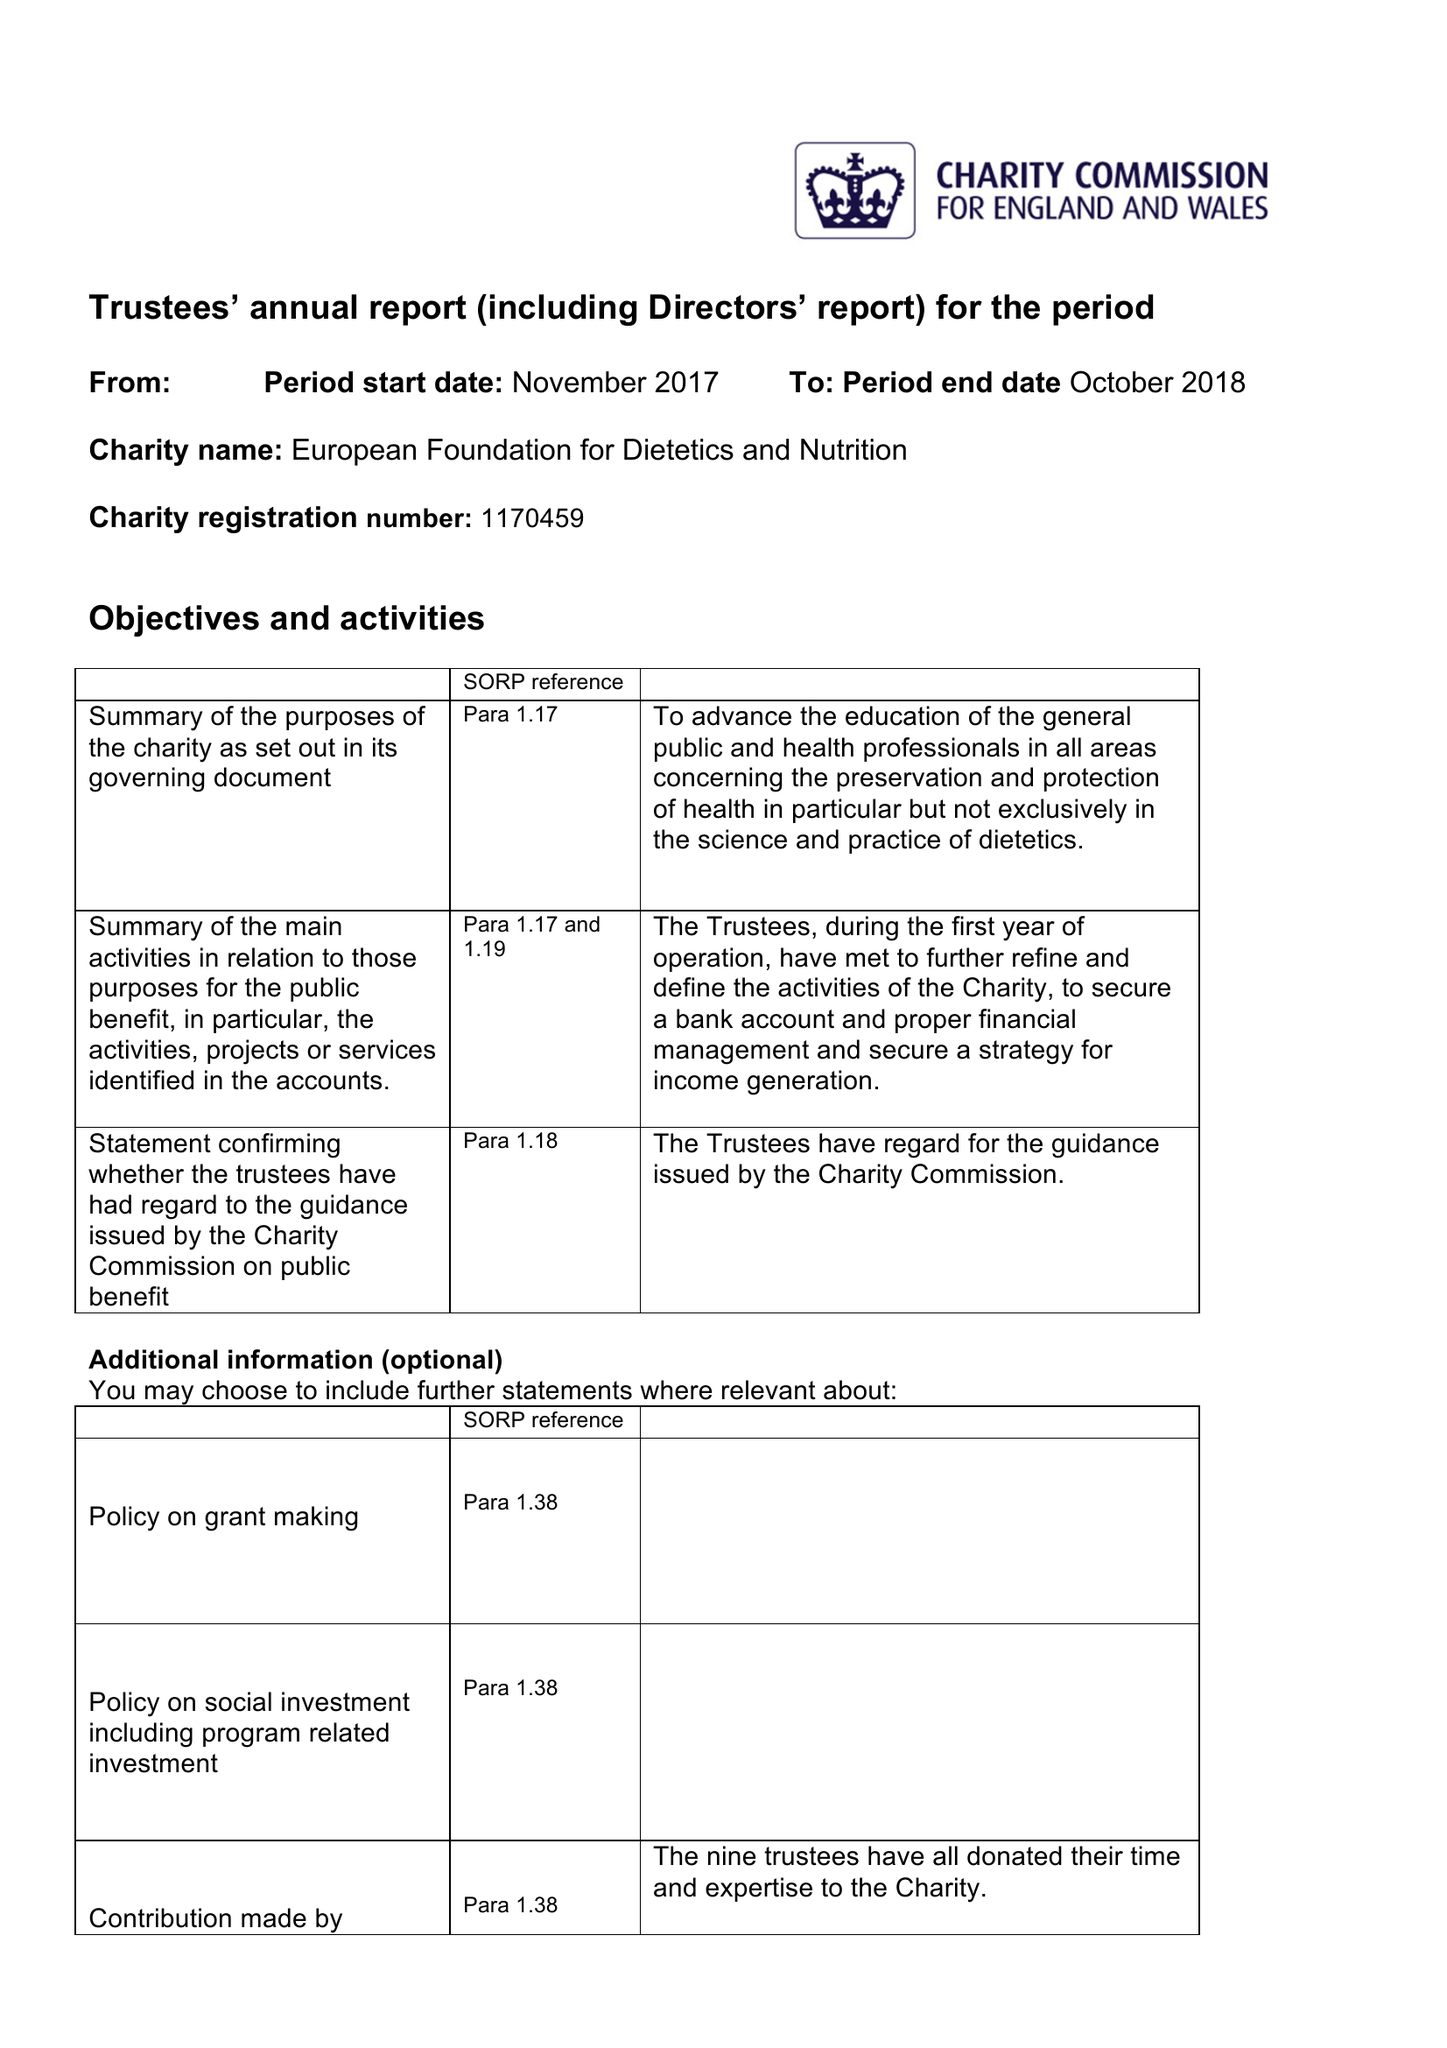What is the value for the address__street_line?
Answer the question using a single word or phrase. 148 GREAT CHARLES STREET QUEENSWAY 